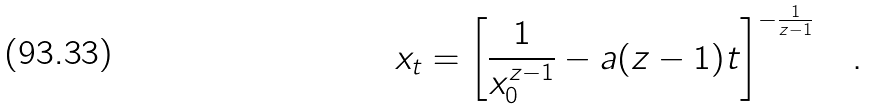<formula> <loc_0><loc_0><loc_500><loc_500>x _ { t } = \left [ \frac { 1 } { x _ { 0 } ^ { z - 1 } } - a ( z - 1 ) t \right ] ^ { - \frac { 1 } { z - 1 } } \quad .</formula> 